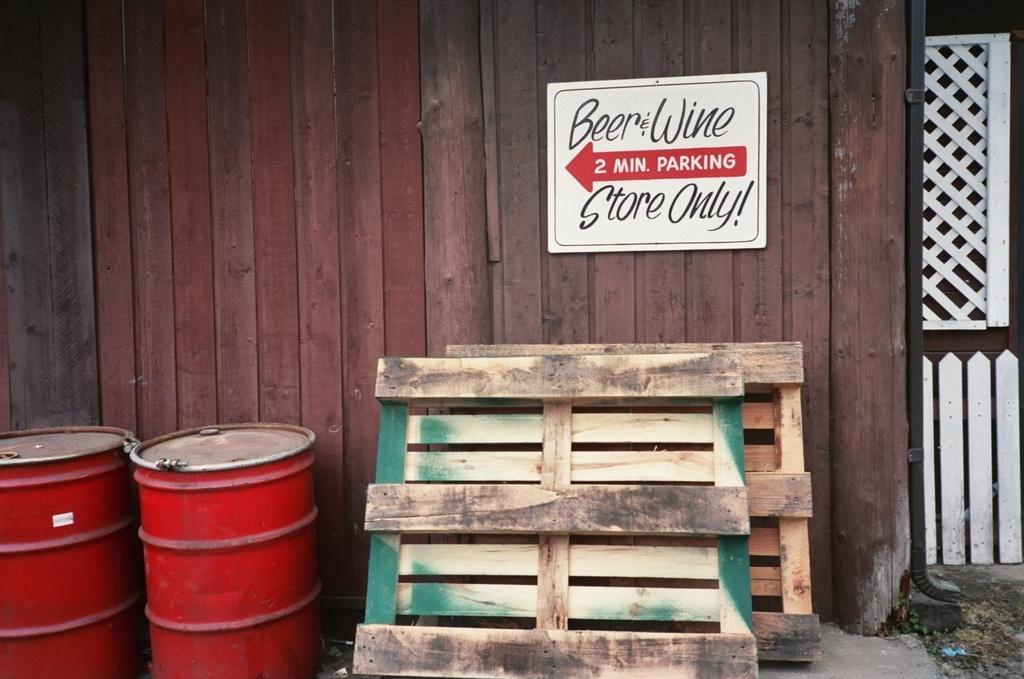Can you describe this image briefly? In this image we can see wooden fence, pipeline, information board, drums and wooden planks. 